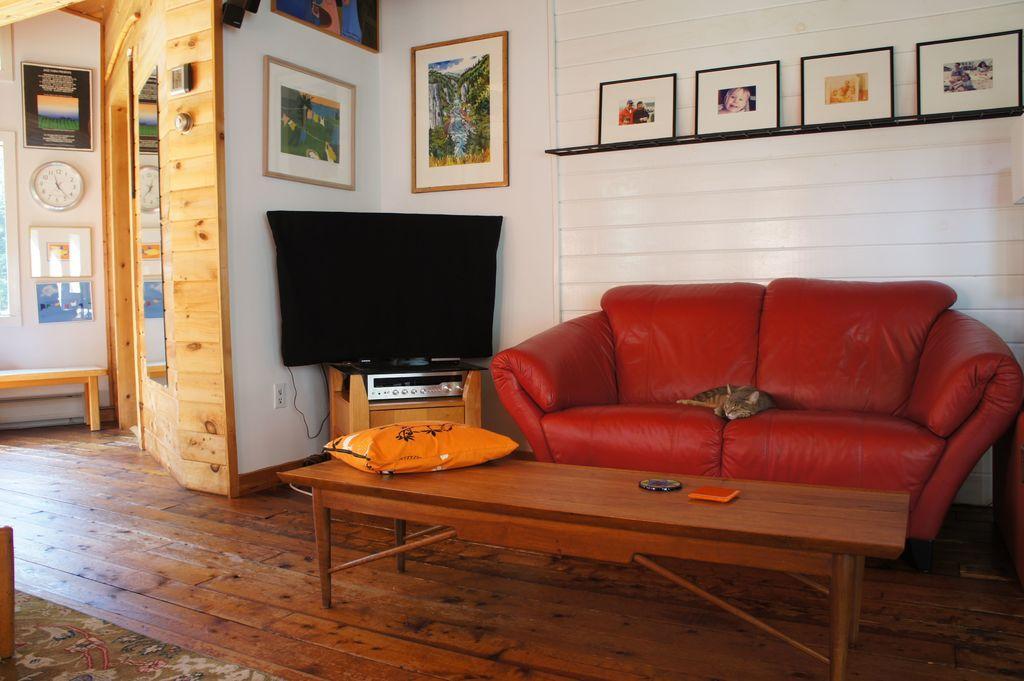Please provide a concise description of this image. In this image, there is an inside view of a house. There is TV in the center of the image. There is a couch and table on the right of the image. There is a cat on the couch. There is clock and some photo frames attached to the wall. 